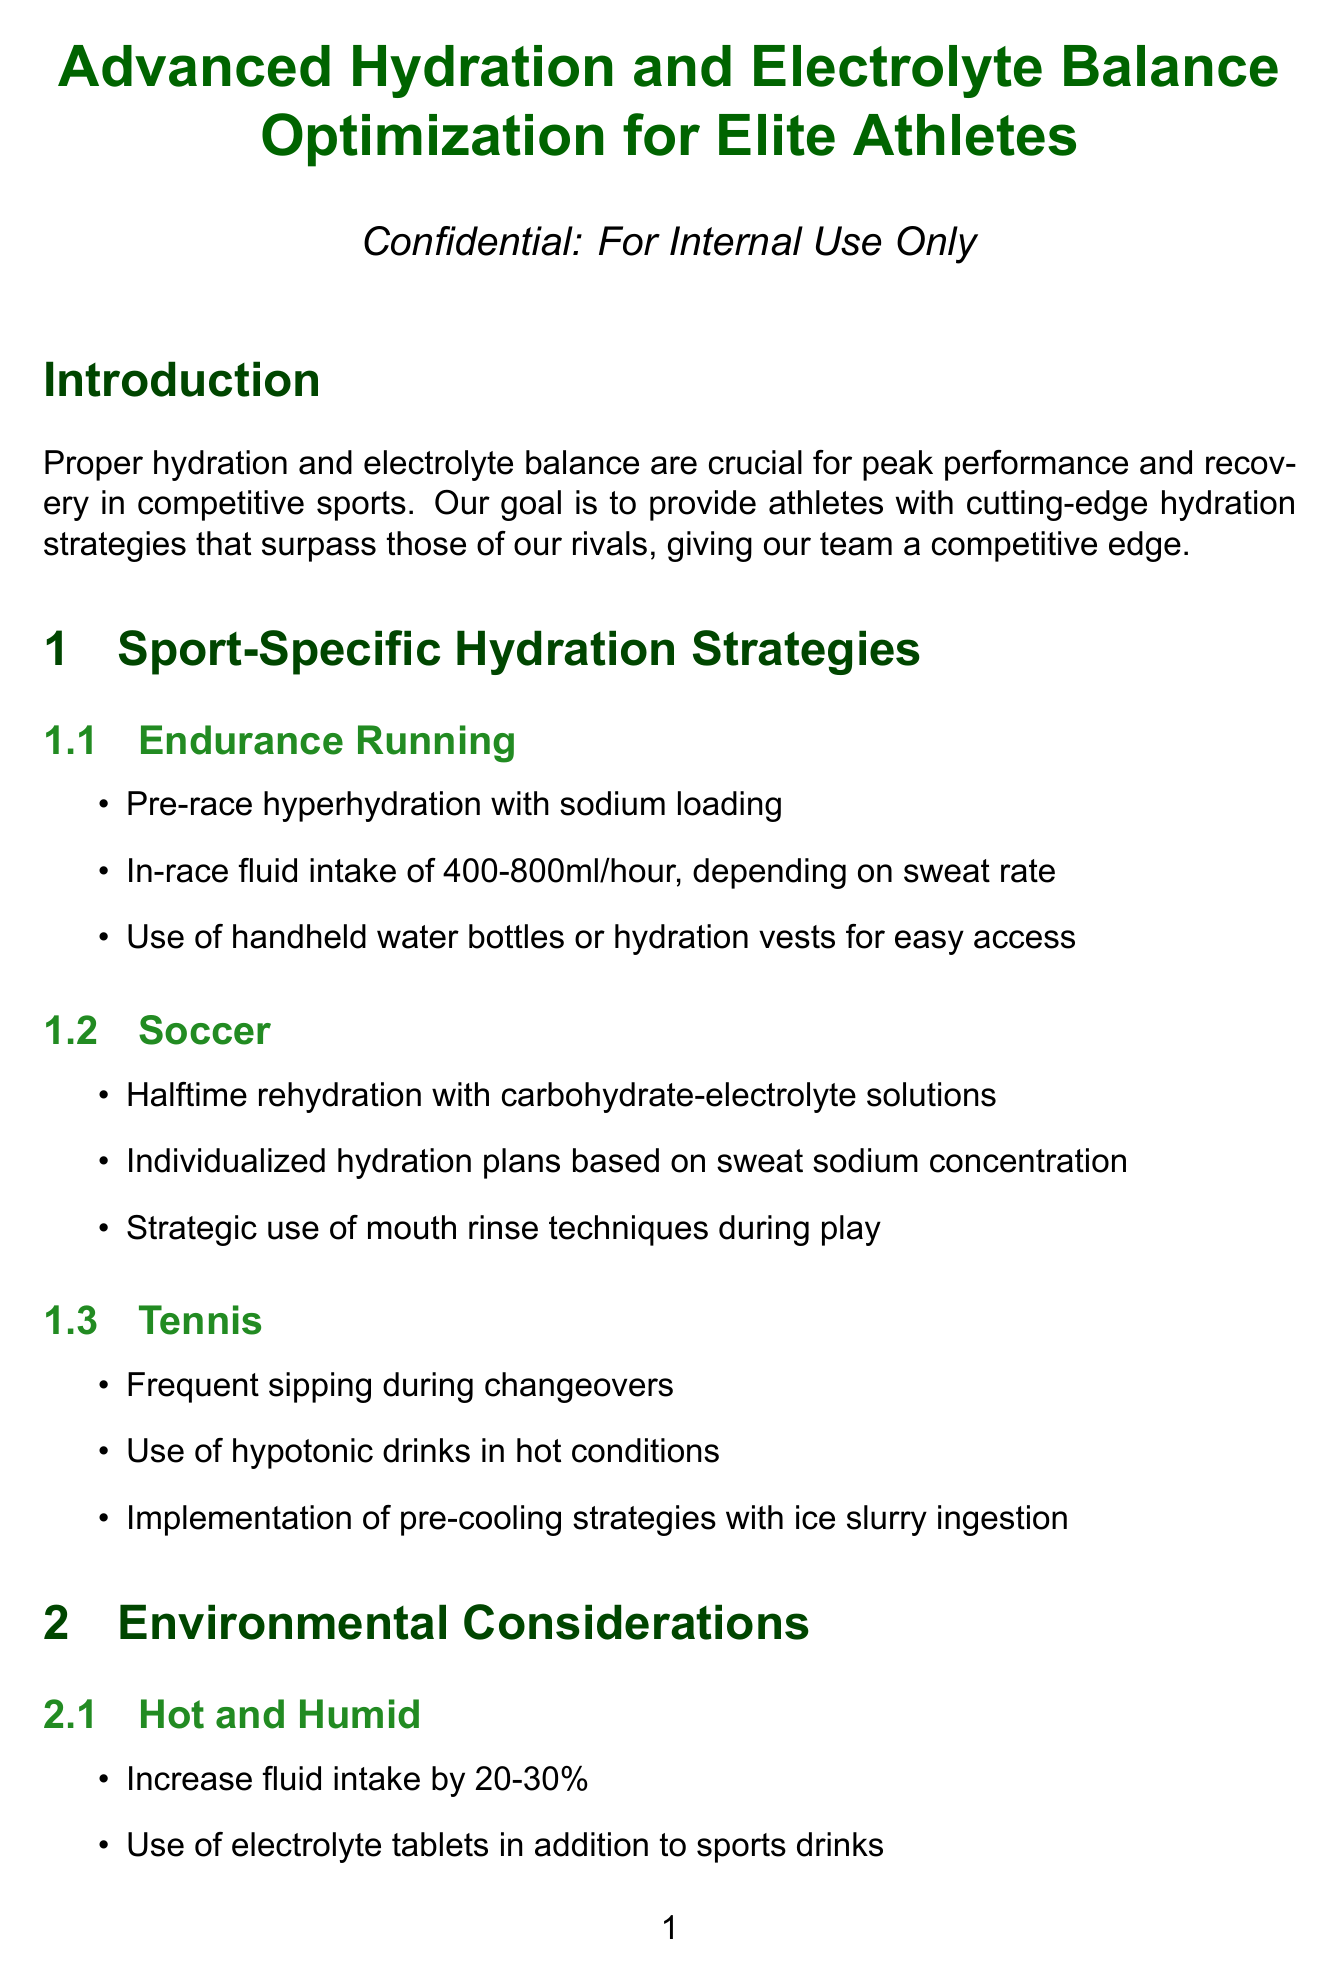What is the title of the manual? The title of the manual is provided at the beginning of the document.
Answer: Advanced Hydration and Electrolyte Balance Optimization for Elite Athletes What is the optimal urine specific gravity range? The optimal range for urine specific gravity is mentioned in the Hydration Monitoring Techniques section.
Answer: 1.005 - 1.020 What is the percentage increase in fluid intake recommended for hot and humid conditions? The document specifies strategies for environmental conditions, including hot and humid.
Answer: 20-30% Which electrolyte is crucial for muscle contractions? The key electrolytes section describes the function of each electrolyte.
Answer: Potassium What method is suggested for post-exercise recovery hydration? The Recovery Hydration Protocols section outlines several strategies for recovery hydration.
Answer: R.A.C.E. method What type of drinks should be used in cold and dry environments? The strategies for cold and dry conditions provide recommendations.
Answer: Warm fluids Which hydration technology measures real-time core temperature? The Cutting-Edge Hydration Technologies section lists several innovations with applications.
Answer: CORE Body Temperature Sensor What is a key takeaway from the conclusion? The conclusion section emphasizes important insights from the manual.
Answer: Individualization is crucial for optimal hydration and electrolyte balance How often should bioelectrical impedance analysis be conducted? The frequency for monitoring using bioelectrical impedance analysis is stated.
Answer: Weekly monitoring 